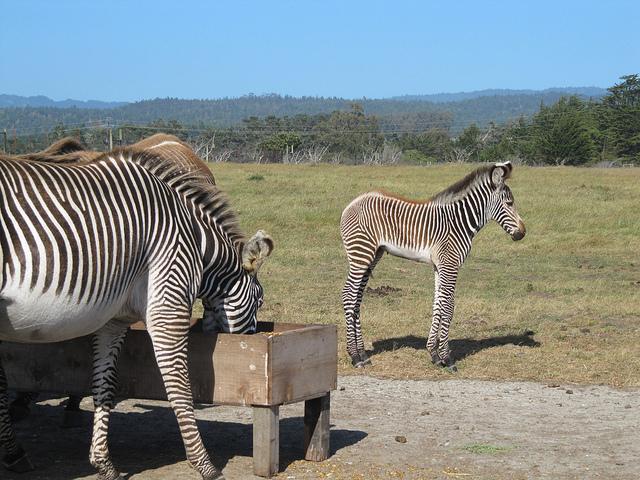How many zebras are visible?
Give a very brief answer. 2. How many feet does this person have on the ground?
Give a very brief answer. 0. 